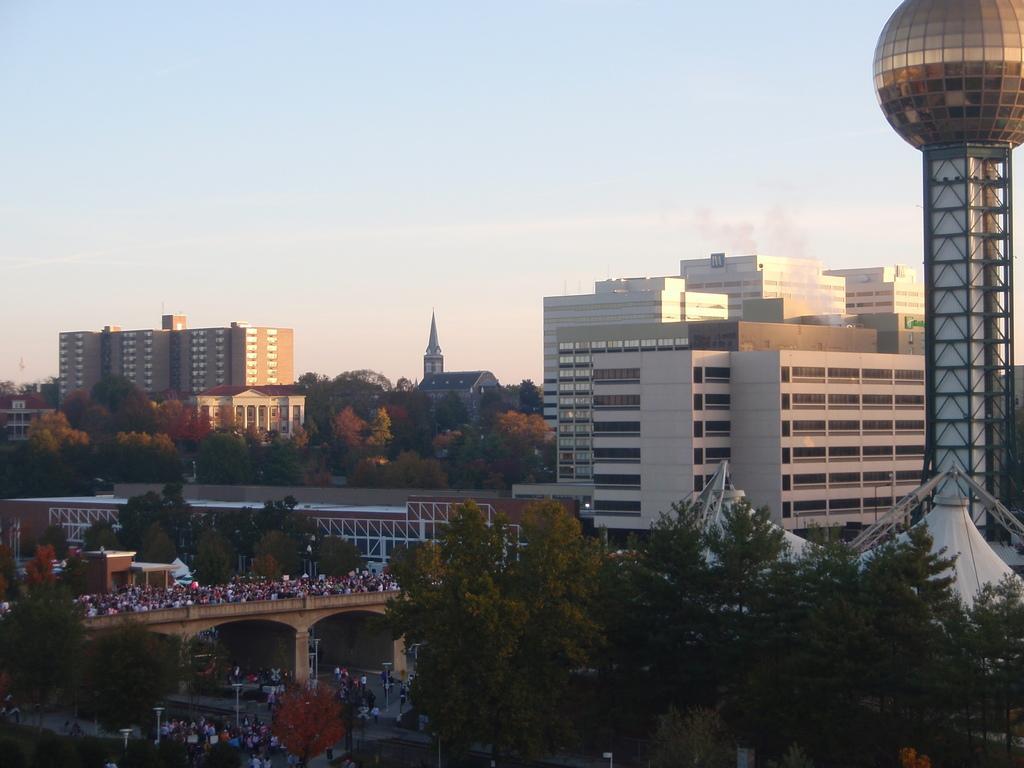In one or two sentences, can you explain what this image depicts? In the picture I can see buildings, trees, roads, people and some other objects. In the background I can see the sky and a tower. 